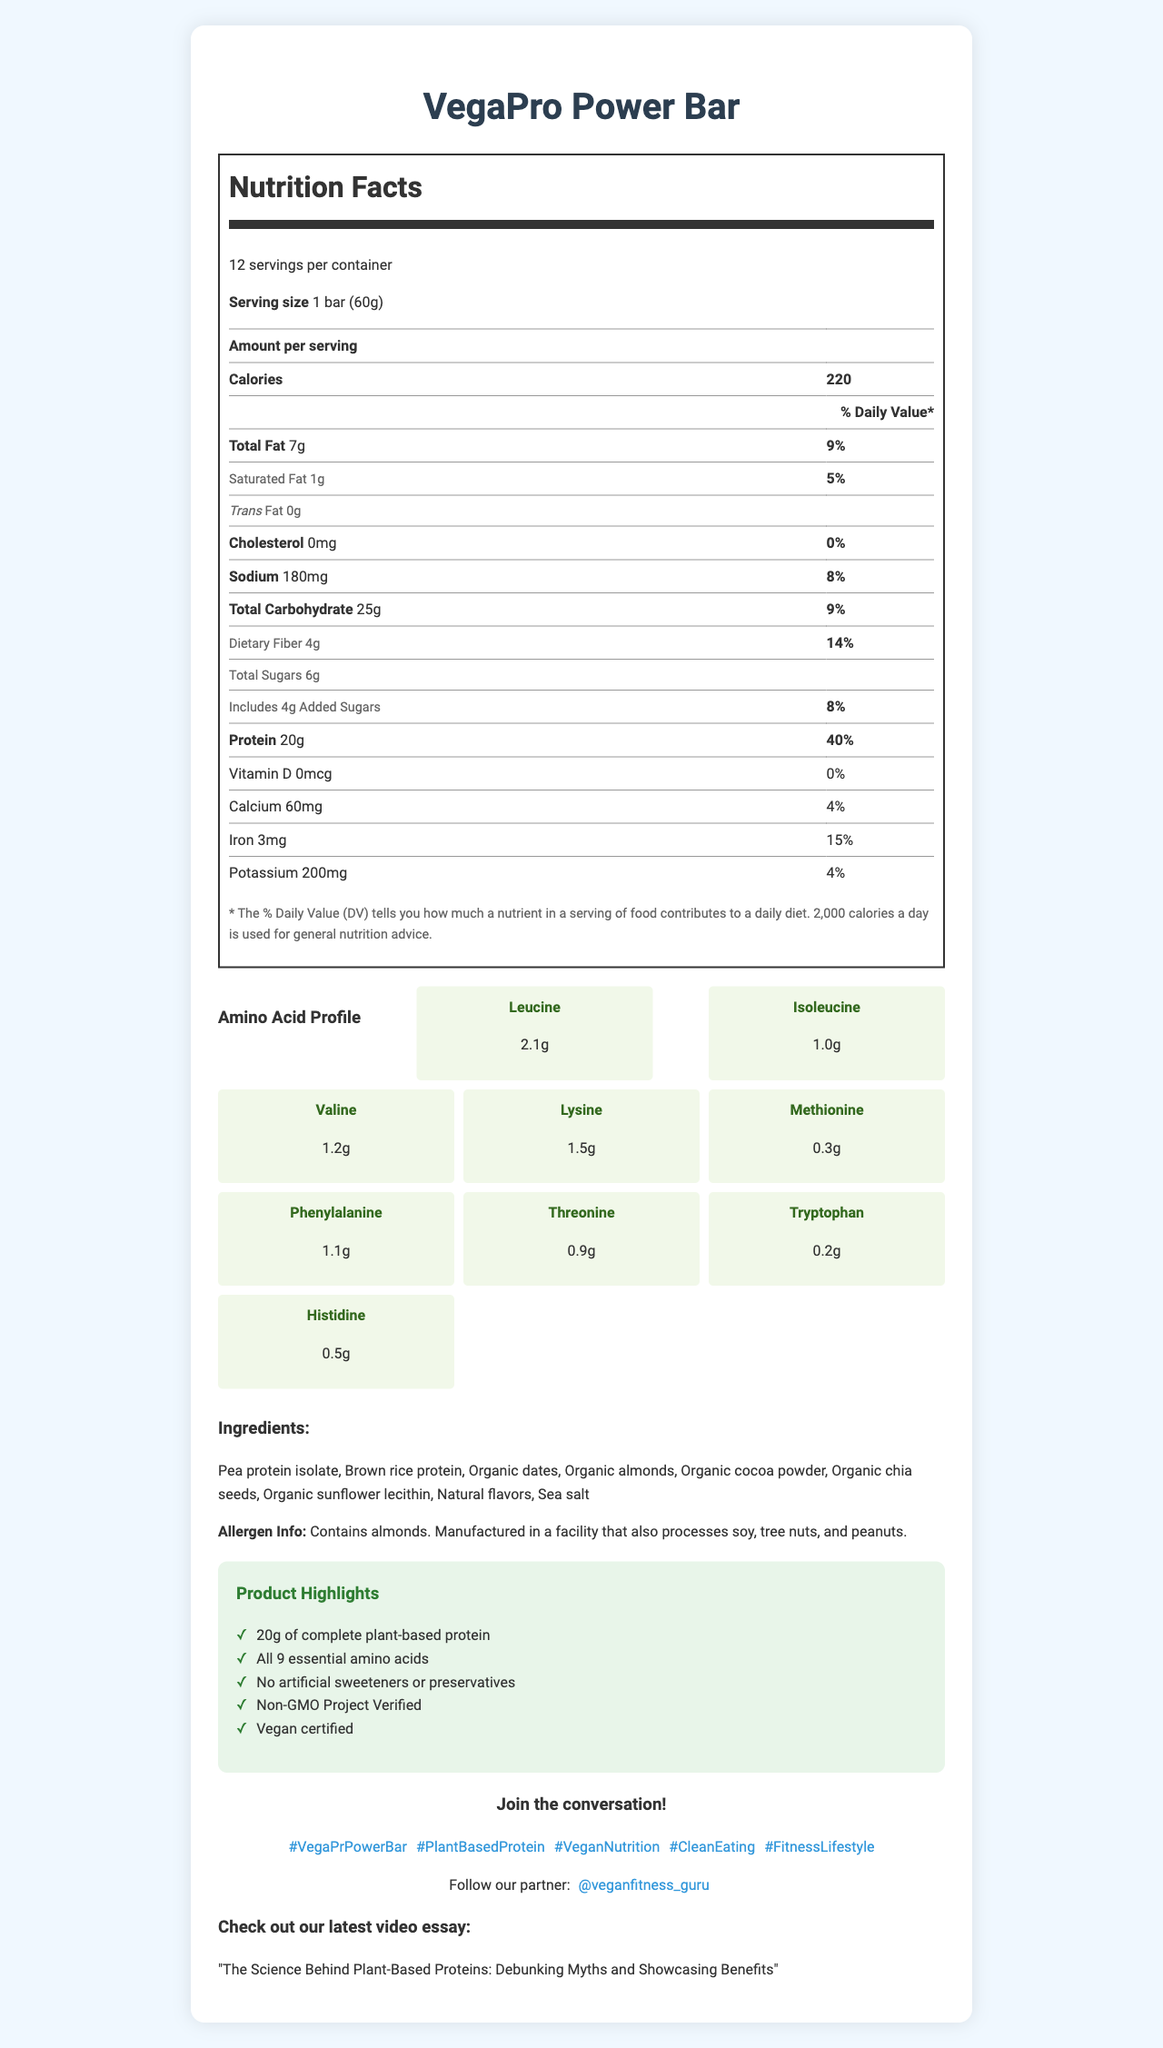What is the serving size for the VegaPro Power Bar? The serving size is clearly stated as "1 bar (60g)" in the nutrition facts section.
Answer: 1 bar (60g) How many calories are in one serving of the VegaPro Power Bar? The number of calories per serving is listed as 220 under the "Amount per serving" section in the nutrition facts.
Answer: 220 What percentage of the daily value is the protein content in the VegaPro Power Bar? The document mentions that the protein content is 20g, which is 40% of the daily value.
Answer: 40% What is the amount of dietary fiber in one serving of the VegaPro Power Bar? According to the nutrition label, the dietary fiber content is 4g per serving.
Answer: 4g Which allergen does the VegaPro Power Bar contain? The document specifies that the bar contains almonds and is manufactured in a facility that also processes soy, tree nuts, and peanuts.
Answer: Almonds How much leucine is found in one VegaPro Power Bar? A. 1.0g B. 1.5g C. 2.1g D. 0.5g The amino acid profile section lists leucine content as 2.1g.
Answer: C. 2.1g Which of the following is not included in the ingredients list? A. Pea protein isolate B. Organic dates C. Artificial sweeteners D. Natural flavors The ingredients list does not mention artificial sweeteners, aligning with the marketing claim of "No artificial sweeteners or preservatives."
Answer: C. Artificial sweeteners Does the VegaPro Power Bar contain cholesterol? The cholesterol content is listed as 0mg in the nutrition facts section.
Answer: No Summarize the main idea of the document. The document emphasizes the health benefits, nutritional content, and specific attributes that make the VegaPro Power Bar a desirable option for those seeking a plant-based protein source.
Answer: The VegaPro Power Bar is a plant-based protein bar that provides a comprehensive nutritional profile with 20g of complete protein and all 9 essential amino acids. It's vegan, non-GMO, and free of artificial sweeteners and preservatives, making it a suitable choice for health-conscious consumers and those following a vegan diet. The document also provides detailed information on nutritional content, ingredients, allergen information, and product highlights. What is the daily value percentage of iron in one serving of the VegaPro Power Bar? The nutrition facts section lists iron content as 3mg, which corresponds to 15% of the daily value.
Answer: 15% Which social media hashtags are recommended for talking about the VegaPro Power Bar? The document lists these hashtags under the social media section.
Answer: #VegaProPowerBar, #PlantBasedProtein, #VeganNutrition, #CleanEating, #FitnessLifestyle Who is the influencer partner mentioned in the document? The influencer partnership section mentions "@veganfitness_guru."
Answer: @veganfitness_guru What is the calcium content of the VegaPro Power Bar per serving? The nutrition facts section lists the calcium content as 60mg per serving.
Answer: 60mg What is the video essay topic associated with the VegaPro Power Bar? The video essay section at the bottom of the document states this topic.
Answer: The Science Behind Plant-Based Proteins: Debunking Myths and Showcasing Benefits From which sources are the proteins in the VegaPro Power Bar derived? The ingredients list includes pea protein isolate and brown rice protein as protein sources.
Answer: Pea protein isolate, Brown rice protein Are there any preservatives in the VegaPro Power Bar? The marketing claims state "No artificial sweeteners or preservatives."
Answer: No How many grams of added sugars does the VegaPro Power Bar contain? The nutrition facts section shows that the total added sugars amount to 4g per serving.
Answer: 4g What is the main function of the amino acids leucine, isoleucine, and valine in the VegaPro Power Bar? The amino acid profile highlights key BCAAs like leucine (2.1g), isoleucine (1.0g), and valine (1.2g) known for supporting muscle recovery and protein synthesis after exercise.
Answer: These amino acids are part of the branch chain amino acids (BCAAs) which help in muscle recovery and synthesis. What is the exact amount of potassium in one serving of the VegaPro Power Bar? The nutrition facts section lists the potassium content as 200mg per serving.
Answer: 200mg How many total servings are in one container of the VegaPro Power Bar? The top of the nutrition facts section indicates that there are 12 servings per container.
Answer: 12 What is the amount of phenylalanine per serving of the VegaPro Power Bar? The amino acid profile section mentions phenylalanine content as 1.1g.
Answer: 1.1g What is the manufacturing facility allergen risk mentioned? The allergen information indicates that the bar is manufactured in a facility that processes soy, tree nuts, and peanuts—not just almonds.
Answer: Soy, tree nuts, and peanuts What is the sodium content in each serving of the VegaPro Power Bar? The nutrition facts section shows that each serving contains 180mg of sodium.
Answer: 180mg What is the role of threonine in the VegaPro Power Bar? The document lists threonine content but does not explain its role, making it impossible to determine from the visual information alone.
Answer: Not enough information 